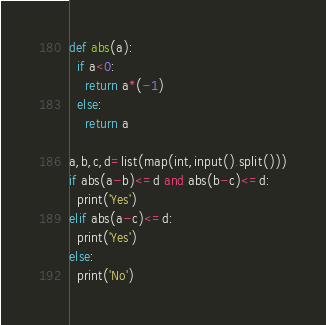<code> <loc_0><loc_0><loc_500><loc_500><_Python_>def abs(a):
  if a<0:
    return a*(-1)
  else:
    return a

a,b,c,d=list(map(int,input().split()))
if abs(a-b)<=d and abs(b-c)<=d:
  print('Yes')
elif abs(a-c)<=d:
  print('Yes')
else:
  print('No')
</code> 